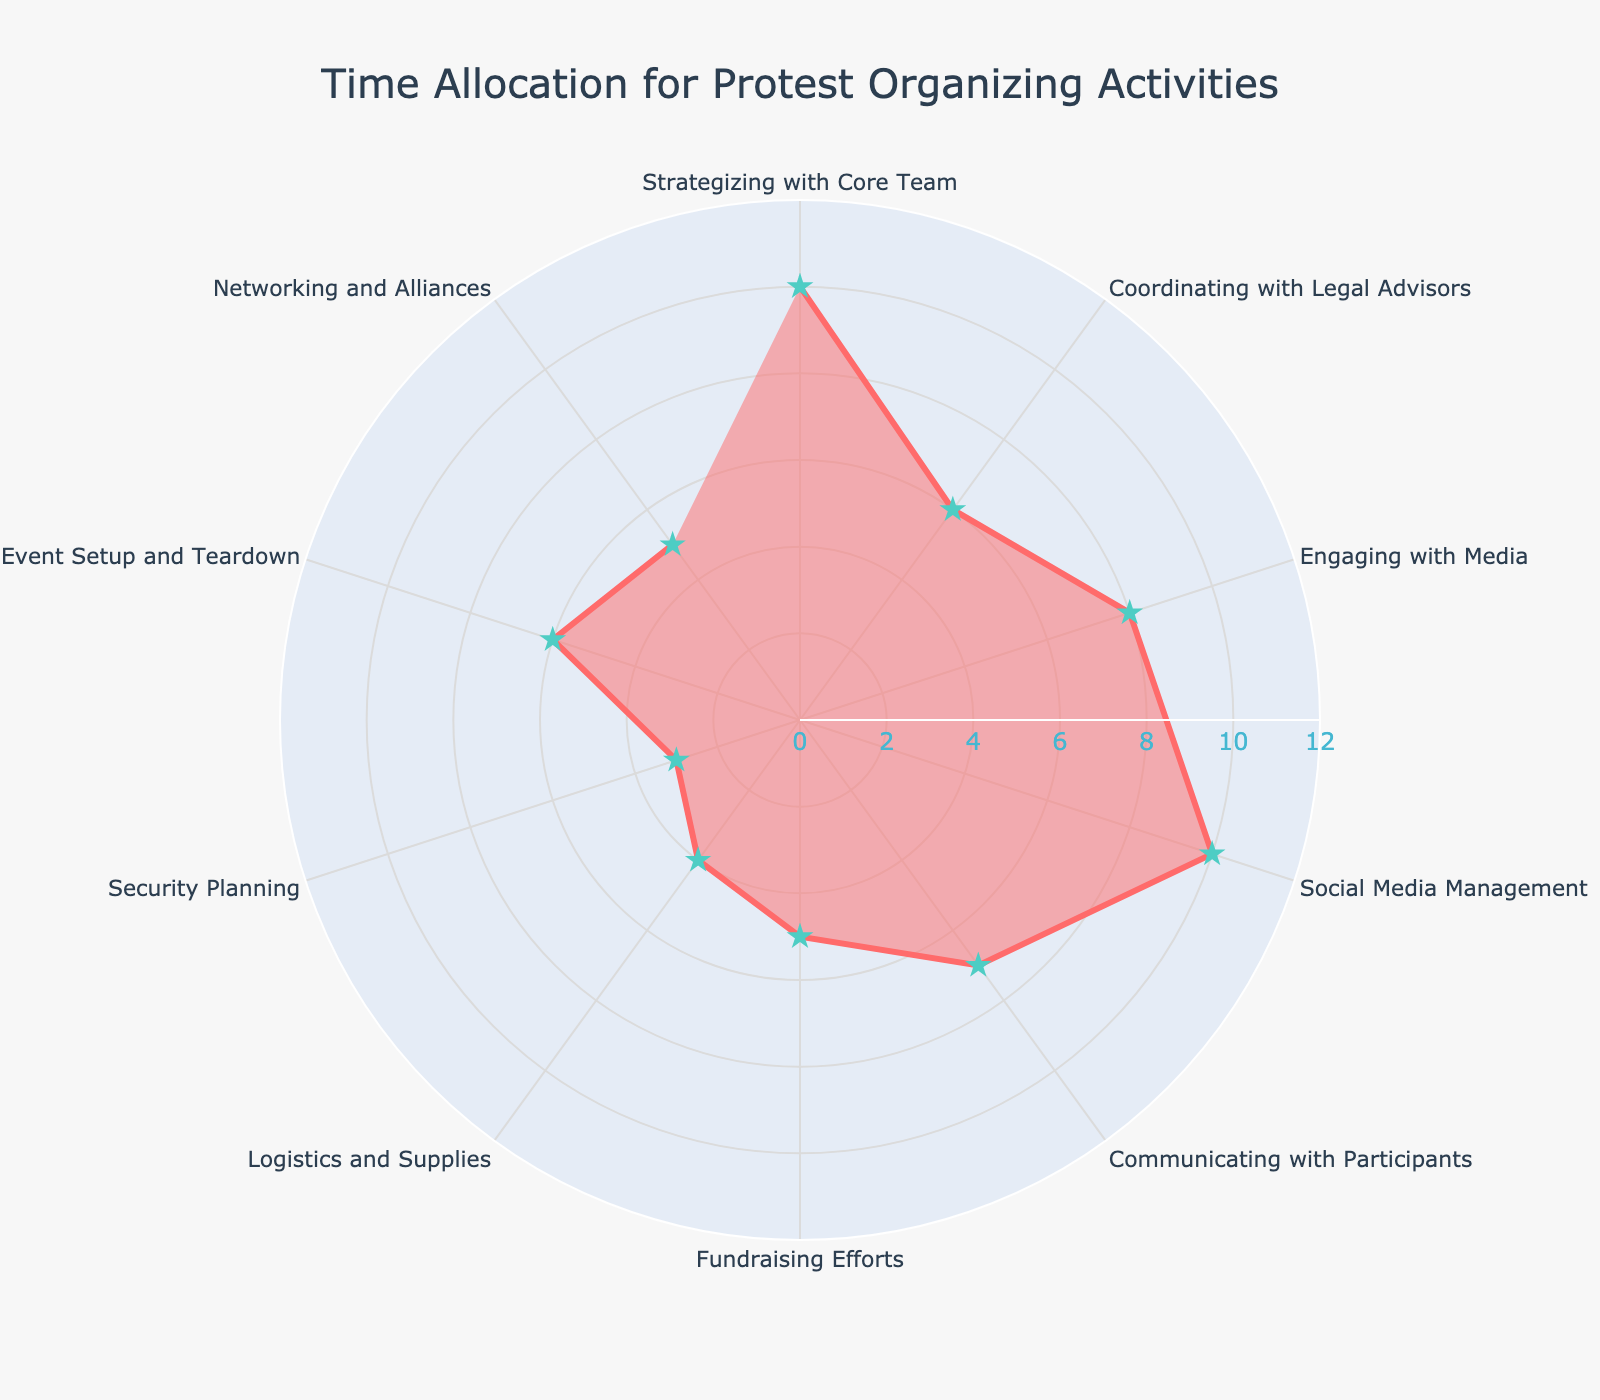What's the title of the figure? The title is usually placed at the top of the figure and often describes the overall theme or purpose of the chart. In this plot, the title is clearly displayed
Answer: Time Allocation for Protest Organizing Activities What activity takes the same amount of time as Social Media Management? Social Media Management is at one of the highest points on the chart with 10 hours. Another activity at the same level is Strategizing with Core Team
Answer: Strategizing with Core Team Which activity takes the least amount of time? To find the least allocated time, look for the smallest radial span. Security Planning has the smallest length in the chart
Answer: Security Planning How many activities take more than 6 hours? Identify all activities with a radial span greater than 6 hours: Strategizing with Core Team (10), Social Media Management (10), Engaging with Media (8), and Communicating with Participants (7). Thus, 4 activities
Answer: 4 What is the combined time spent on Coordinating with Legal Advisors and Event Setup and Teardown? Sum the hours for both activities: Coordinating with Legal Advisors (6) + Event Setup and Teardown (6) = 12 hours
Answer: 12 On which activity do protest leaders spend as much time as Engaging with Media and Fundraising Efforts combined? Engaging with Media is 8 hours, and Fundraising Efforts is 5 hours. Combined time is 8 + 5 = 13 hours. There is no activity that has exactly 13 hours on the chart
Answer: None What is the average time spent on all activities? Sum all the hours and divide by the number of activities. Total hours: 10+6+8+10+7+5+4+3+6+5 = 64. There are 10 activities. Average time is 64 / 10 = 6.4 hours
Answer: 6.4 hours Which two activities combined account for an equal amount of time as Social Media Management? Social Media Management is 10 hours. Fundraising Efforts (5) and Networking and Alliances (5) combined are 5 + 5 = 10 hours
Answer: Fundraising Efforts and Networking and Alliances Which activity involves more time: Communicating with Participants or Fundraising Efforts? Compare the radial spans of Communicating with Participants (7 hours) and Fundraising Efforts (5 hours). The former is longer
Answer: Communicating with Participants Are there any activities that require exactly 4 hours? Look for a radial span of 4 hours. Logistics and Supplies satisfy this condition
Answer: Logistics and Supplies 